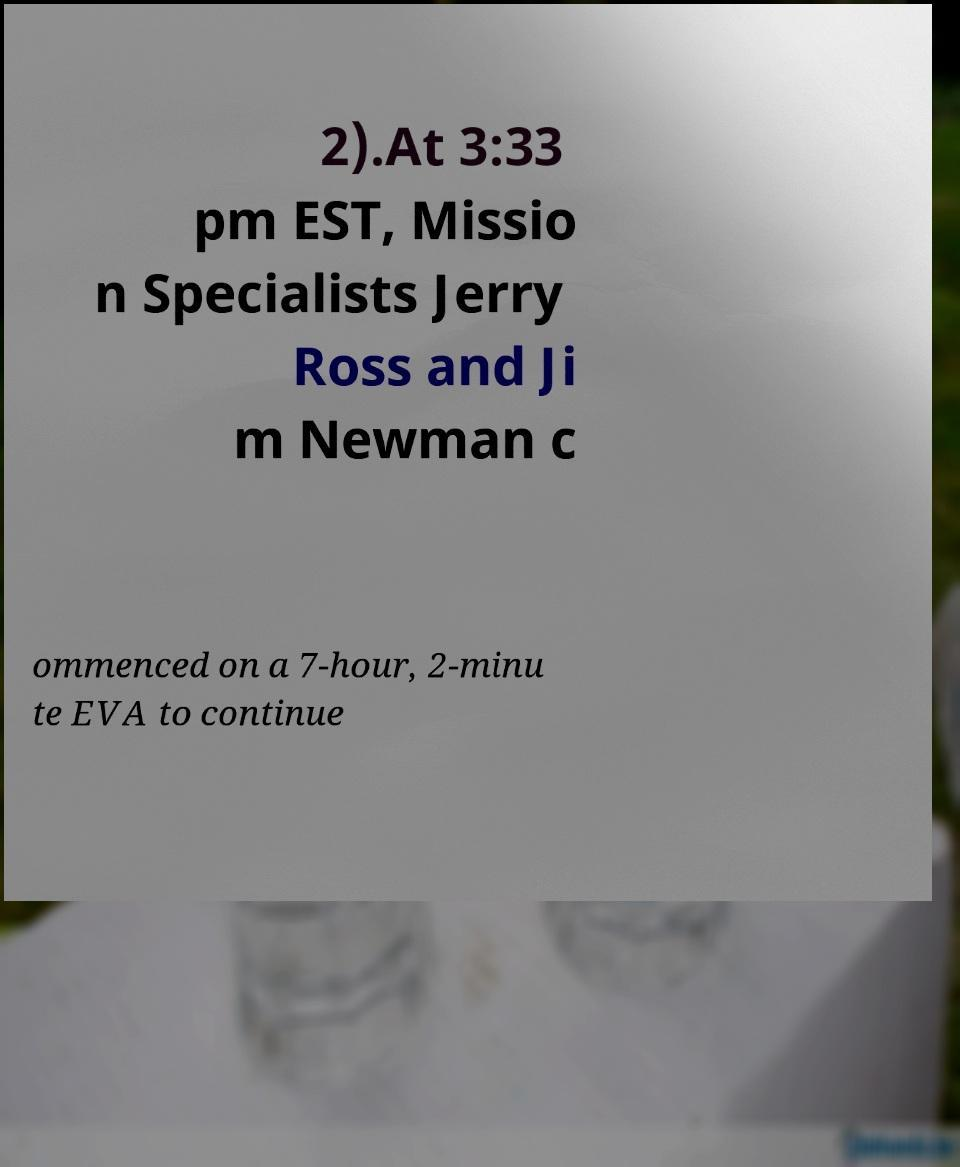For documentation purposes, I need the text within this image transcribed. Could you provide that? 2).At 3:33 pm EST, Missio n Specialists Jerry Ross and Ji m Newman c ommenced on a 7-hour, 2-minu te EVA to continue 